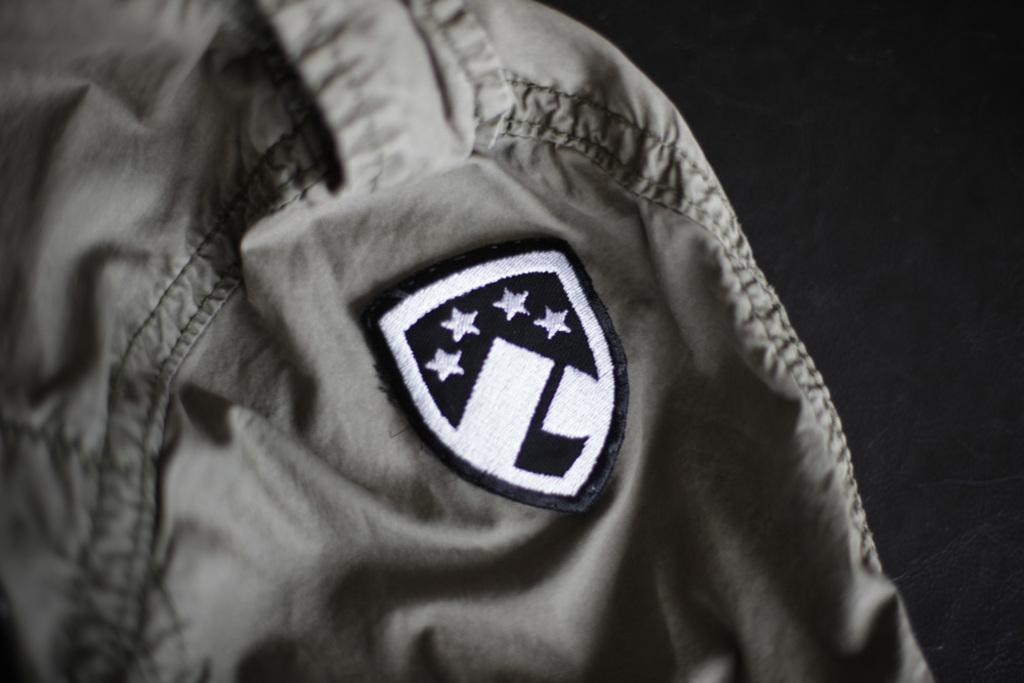What is on the shoulder of the shirt in the image? There is a badge on the shoulder of the shirt in the image. How many stars are on the badge? The badge has 4 stars on it. What type of pets are visible near the hydrant in the image? There is no hydrant or pets present in the image; it only features a badge with 4 stars on a shirt. 